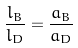Convert formula to latex. <formula><loc_0><loc_0><loc_500><loc_500>\frac { l _ { B } } { l _ { D } } = \frac { a _ { B } } { a _ { D } }</formula> 